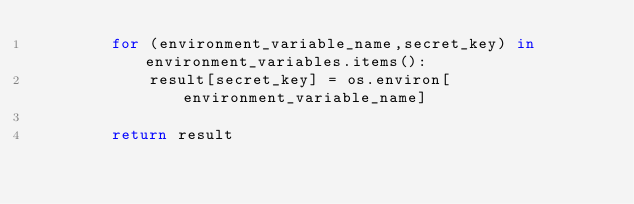Convert code to text. <code><loc_0><loc_0><loc_500><loc_500><_Python_>        for (environment_variable_name,secret_key) in environment_variables.items():
            result[secret_key] = os.environ[environment_variable_name]

        return result
</code> 